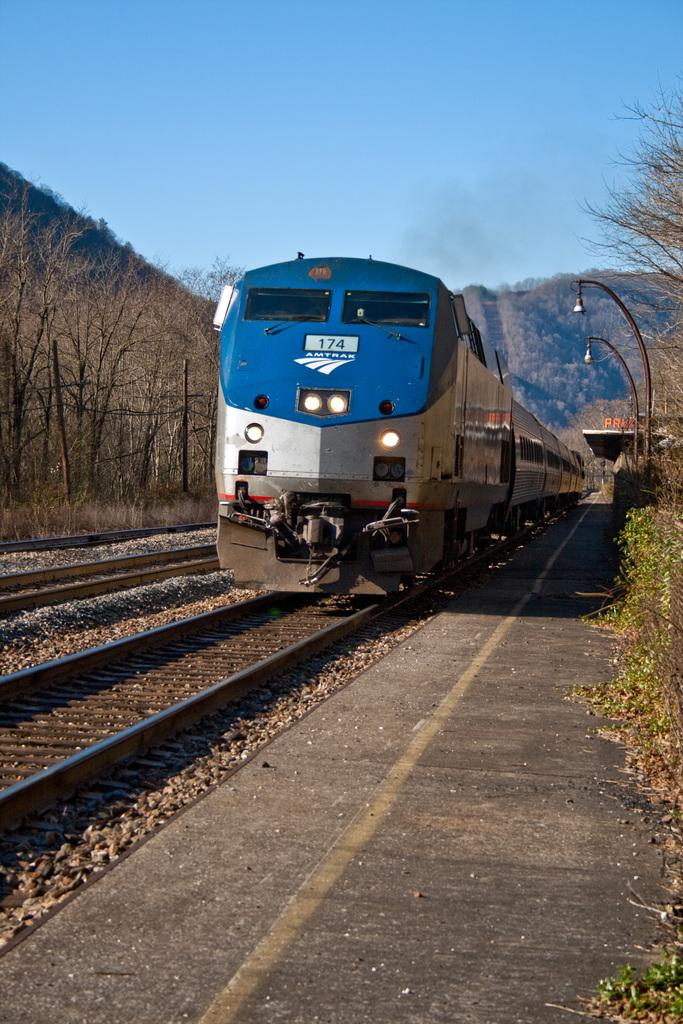What is the main subject of the image? There is a train in the image. What is the train's position in relation to the tracks? The train is on a track. What can be seen on both sides of the train? There are trees on the right side and the left side of the train. What is visible in the background of the image? There is a mountain and the sky in the background of the image. How many lizards are sitting on the train in the image? There are no lizards present in the image. What type of currency is being exchanged on the train in the image? There is no currency exchange or money visible in the image. 